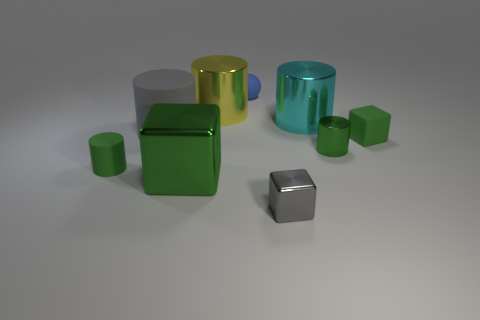What size is the metallic block that is the same color as the tiny metal cylinder?
Your answer should be very brief. Large. Are there any big spheres that have the same color as the small metal block?
Keep it short and to the point. No. There is a rubber thing that is on the right side of the blue object; is it the same color as the small thing that is to the left of the small blue rubber ball?
Your answer should be very brief. Yes. There is a green cube that is in front of the green shiny cylinder; what is it made of?
Your answer should be compact. Metal. What is the color of the block that is the same material as the blue thing?
Provide a succinct answer. Green. How many things are the same size as the matte cube?
Provide a short and direct response. 4. Do the green block that is to the left of the yellow cylinder and the cyan cylinder have the same size?
Offer a very short reply. Yes. There is a green thing that is on the left side of the ball and behind the large green thing; what shape is it?
Keep it short and to the point. Cylinder. Are there any green metallic cylinders in front of the small green rubber cylinder?
Your answer should be very brief. No. Are there any other things that have the same shape as the big cyan metallic object?
Provide a succinct answer. Yes. 